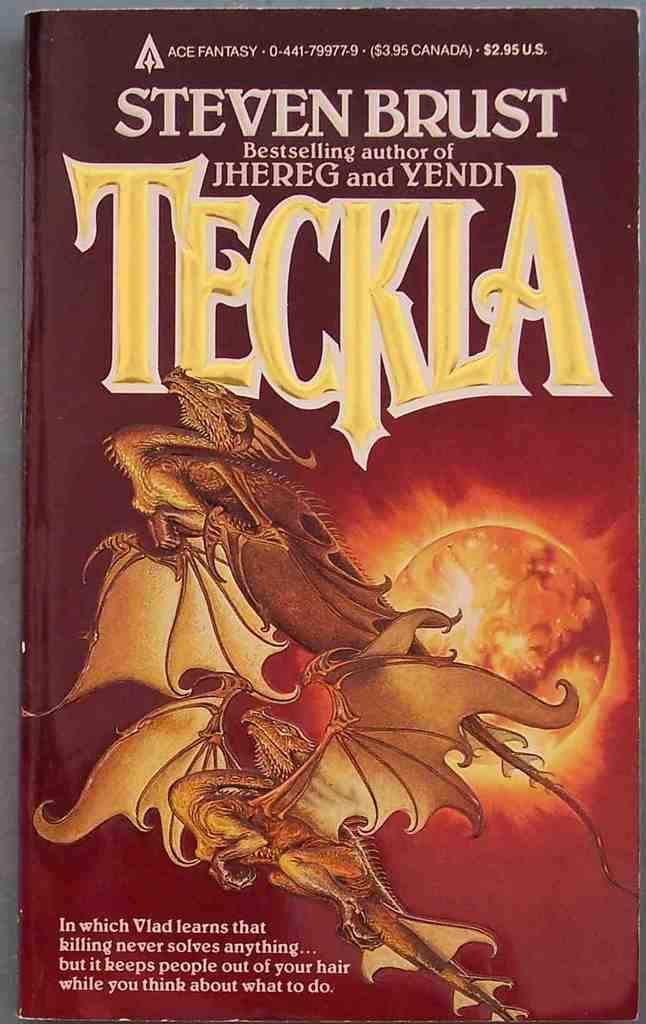<image>
Write a terse but informative summary of the picture. The book shown here is written by a best selling author. 